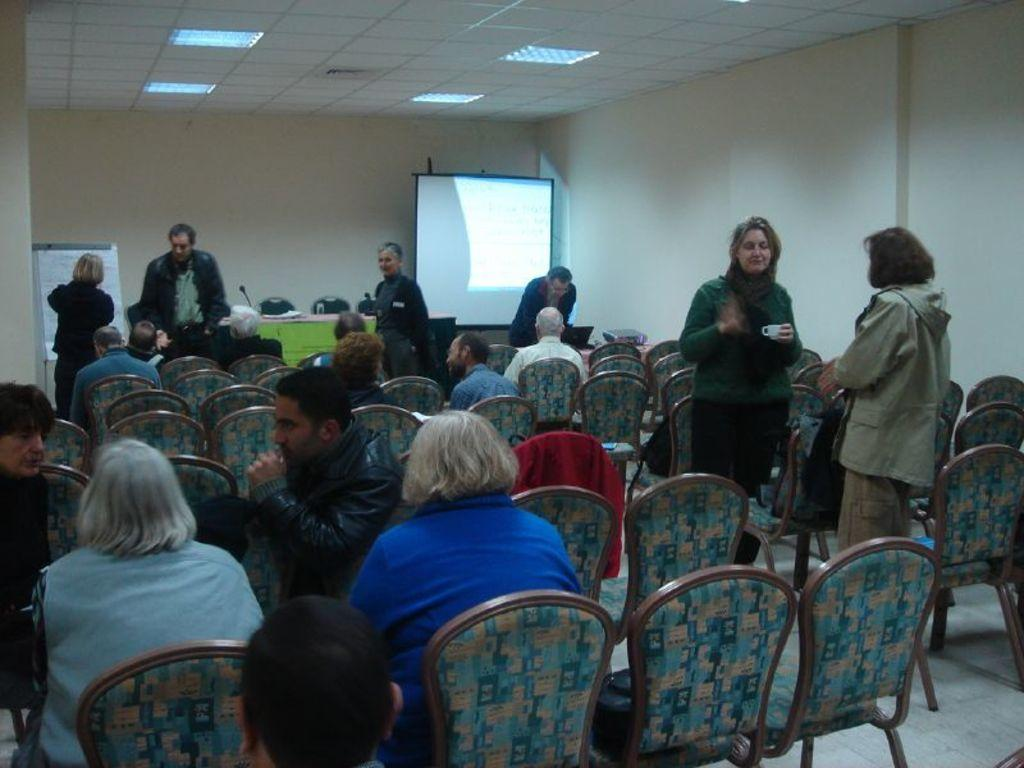What are the people in the image doing? There is a group of people sitting in the image. What are the sitting people using to support themselves? The group is sitting in chairs. What is happening in the background of the image? There are people standing in the background. What can be seen on the wall in the image? There is a screen in the image. What is the primary architectural feature in the image? There is a wall in the image. Can you see any toes sticking out from under the chairs in the image? There is no indication of toes or feet visible in the image, as the focus is on the people sitting in chairs. 